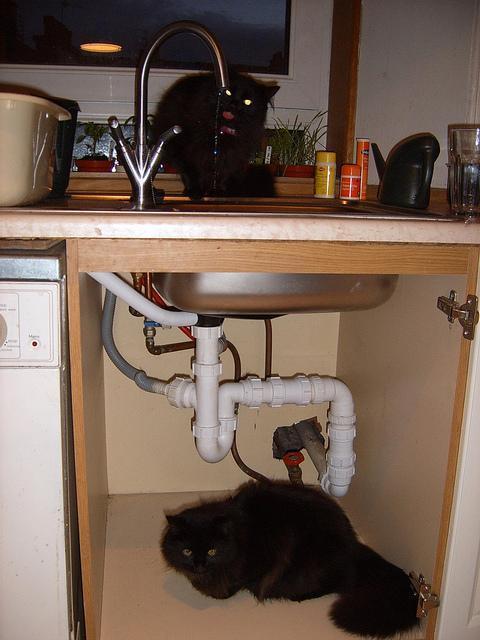How many cats are in the picture?
Give a very brief answer. 2. How many cats are there?
Give a very brief answer. 2. 